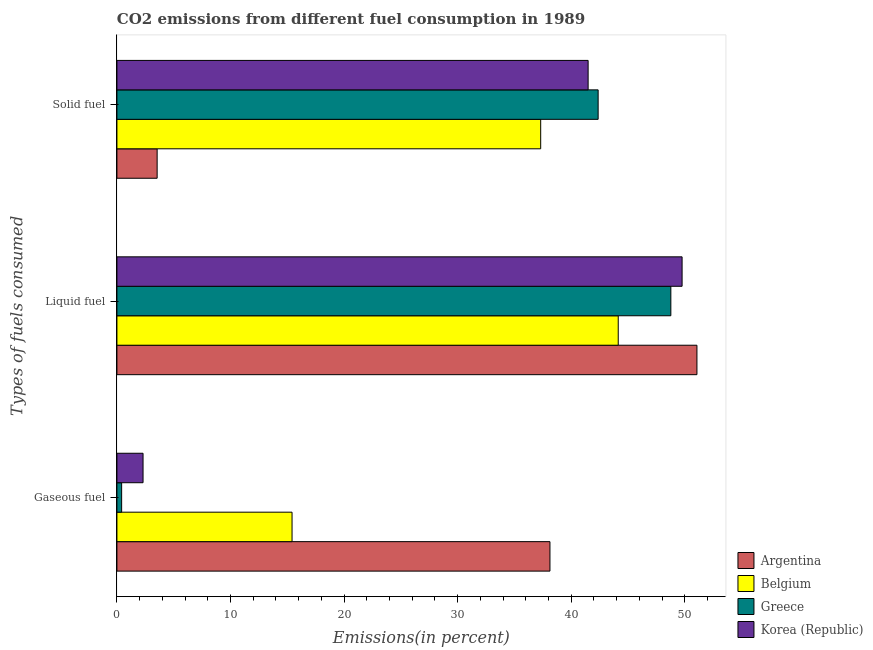Are the number of bars per tick equal to the number of legend labels?
Give a very brief answer. Yes. Are the number of bars on each tick of the Y-axis equal?
Offer a terse response. Yes. What is the label of the 1st group of bars from the top?
Your answer should be compact. Solid fuel. What is the percentage of liquid fuel emission in Korea (Republic)?
Offer a terse response. 49.77. Across all countries, what is the maximum percentage of liquid fuel emission?
Provide a succinct answer. 51.07. Across all countries, what is the minimum percentage of liquid fuel emission?
Your answer should be very brief. 44.14. In which country was the percentage of solid fuel emission minimum?
Keep it short and to the point. Argentina. What is the total percentage of solid fuel emission in the graph?
Your answer should be very brief. 124.72. What is the difference between the percentage of solid fuel emission in Argentina and that in Belgium?
Offer a very short reply. -33.77. What is the difference between the percentage of liquid fuel emission in Argentina and the percentage of gaseous fuel emission in Greece?
Your answer should be very brief. 50.66. What is the average percentage of liquid fuel emission per country?
Keep it short and to the point. 48.44. What is the difference between the percentage of gaseous fuel emission and percentage of liquid fuel emission in Greece?
Provide a succinct answer. -48.36. What is the ratio of the percentage of liquid fuel emission in Argentina to that in Greece?
Your answer should be very brief. 1.05. What is the difference between the highest and the second highest percentage of gaseous fuel emission?
Provide a succinct answer. 22.71. What is the difference between the highest and the lowest percentage of liquid fuel emission?
Your response must be concise. 6.93. What does the 2nd bar from the top in Liquid fuel represents?
Your response must be concise. Greece. What does the 1st bar from the bottom in Liquid fuel represents?
Provide a short and direct response. Argentina. Is it the case that in every country, the sum of the percentage of gaseous fuel emission and percentage of liquid fuel emission is greater than the percentage of solid fuel emission?
Give a very brief answer. Yes. Are all the bars in the graph horizontal?
Give a very brief answer. Yes. How many countries are there in the graph?
Ensure brevity in your answer.  4. Are the values on the major ticks of X-axis written in scientific E-notation?
Provide a succinct answer. No. Does the graph contain grids?
Give a very brief answer. No. What is the title of the graph?
Your response must be concise. CO2 emissions from different fuel consumption in 1989. What is the label or title of the X-axis?
Give a very brief answer. Emissions(in percent). What is the label or title of the Y-axis?
Your response must be concise. Types of fuels consumed. What is the Emissions(in percent) of Argentina in Gaseous fuel?
Offer a terse response. 38.13. What is the Emissions(in percent) of Belgium in Gaseous fuel?
Ensure brevity in your answer.  15.42. What is the Emissions(in percent) of Greece in Gaseous fuel?
Offer a very short reply. 0.42. What is the Emissions(in percent) in Korea (Republic) in Gaseous fuel?
Your answer should be compact. 2.3. What is the Emissions(in percent) in Argentina in Liquid fuel?
Ensure brevity in your answer.  51.07. What is the Emissions(in percent) of Belgium in Liquid fuel?
Ensure brevity in your answer.  44.14. What is the Emissions(in percent) of Greece in Liquid fuel?
Your answer should be compact. 48.77. What is the Emissions(in percent) in Korea (Republic) in Liquid fuel?
Give a very brief answer. 49.77. What is the Emissions(in percent) of Argentina in Solid fuel?
Provide a succinct answer. 3.54. What is the Emissions(in percent) in Belgium in Solid fuel?
Provide a succinct answer. 37.31. What is the Emissions(in percent) of Greece in Solid fuel?
Provide a short and direct response. 42.37. What is the Emissions(in percent) in Korea (Republic) in Solid fuel?
Offer a very short reply. 41.49. Across all Types of fuels consumed, what is the maximum Emissions(in percent) in Argentina?
Give a very brief answer. 51.07. Across all Types of fuels consumed, what is the maximum Emissions(in percent) in Belgium?
Provide a short and direct response. 44.14. Across all Types of fuels consumed, what is the maximum Emissions(in percent) of Greece?
Your answer should be compact. 48.77. Across all Types of fuels consumed, what is the maximum Emissions(in percent) of Korea (Republic)?
Your answer should be compact. 49.77. Across all Types of fuels consumed, what is the minimum Emissions(in percent) of Argentina?
Offer a very short reply. 3.54. Across all Types of fuels consumed, what is the minimum Emissions(in percent) in Belgium?
Give a very brief answer. 15.42. Across all Types of fuels consumed, what is the minimum Emissions(in percent) of Greece?
Ensure brevity in your answer.  0.42. Across all Types of fuels consumed, what is the minimum Emissions(in percent) of Korea (Republic)?
Your answer should be very brief. 2.3. What is the total Emissions(in percent) of Argentina in the graph?
Offer a terse response. 92.74. What is the total Emissions(in percent) in Belgium in the graph?
Offer a very short reply. 96.88. What is the total Emissions(in percent) of Greece in the graph?
Provide a succinct answer. 91.56. What is the total Emissions(in percent) of Korea (Republic) in the graph?
Give a very brief answer. 93.56. What is the difference between the Emissions(in percent) in Argentina in Gaseous fuel and that in Liquid fuel?
Offer a very short reply. -12.94. What is the difference between the Emissions(in percent) in Belgium in Gaseous fuel and that in Liquid fuel?
Ensure brevity in your answer.  -28.72. What is the difference between the Emissions(in percent) in Greece in Gaseous fuel and that in Liquid fuel?
Make the answer very short. -48.36. What is the difference between the Emissions(in percent) in Korea (Republic) in Gaseous fuel and that in Liquid fuel?
Your answer should be compact. -47.46. What is the difference between the Emissions(in percent) in Argentina in Gaseous fuel and that in Solid fuel?
Provide a succinct answer. 34.59. What is the difference between the Emissions(in percent) in Belgium in Gaseous fuel and that in Solid fuel?
Provide a succinct answer. -21.89. What is the difference between the Emissions(in percent) of Greece in Gaseous fuel and that in Solid fuel?
Provide a short and direct response. -41.96. What is the difference between the Emissions(in percent) in Korea (Republic) in Gaseous fuel and that in Solid fuel?
Offer a terse response. -39.19. What is the difference between the Emissions(in percent) of Argentina in Liquid fuel and that in Solid fuel?
Provide a succinct answer. 47.53. What is the difference between the Emissions(in percent) of Belgium in Liquid fuel and that in Solid fuel?
Your answer should be compact. 6.83. What is the difference between the Emissions(in percent) of Greece in Liquid fuel and that in Solid fuel?
Give a very brief answer. 6.4. What is the difference between the Emissions(in percent) of Korea (Republic) in Liquid fuel and that in Solid fuel?
Provide a short and direct response. 8.27. What is the difference between the Emissions(in percent) in Argentina in Gaseous fuel and the Emissions(in percent) in Belgium in Liquid fuel?
Provide a succinct answer. -6.01. What is the difference between the Emissions(in percent) in Argentina in Gaseous fuel and the Emissions(in percent) in Greece in Liquid fuel?
Your answer should be compact. -10.64. What is the difference between the Emissions(in percent) of Argentina in Gaseous fuel and the Emissions(in percent) of Korea (Republic) in Liquid fuel?
Your response must be concise. -11.64. What is the difference between the Emissions(in percent) in Belgium in Gaseous fuel and the Emissions(in percent) in Greece in Liquid fuel?
Keep it short and to the point. -33.35. What is the difference between the Emissions(in percent) in Belgium in Gaseous fuel and the Emissions(in percent) in Korea (Republic) in Liquid fuel?
Provide a succinct answer. -34.34. What is the difference between the Emissions(in percent) of Greece in Gaseous fuel and the Emissions(in percent) of Korea (Republic) in Liquid fuel?
Provide a succinct answer. -49.35. What is the difference between the Emissions(in percent) of Argentina in Gaseous fuel and the Emissions(in percent) of Belgium in Solid fuel?
Your response must be concise. 0.81. What is the difference between the Emissions(in percent) of Argentina in Gaseous fuel and the Emissions(in percent) of Greece in Solid fuel?
Offer a very short reply. -4.24. What is the difference between the Emissions(in percent) of Argentina in Gaseous fuel and the Emissions(in percent) of Korea (Republic) in Solid fuel?
Provide a succinct answer. -3.36. What is the difference between the Emissions(in percent) in Belgium in Gaseous fuel and the Emissions(in percent) in Greece in Solid fuel?
Keep it short and to the point. -26.95. What is the difference between the Emissions(in percent) in Belgium in Gaseous fuel and the Emissions(in percent) in Korea (Republic) in Solid fuel?
Ensure brevity in your answer.  -26.07. What is the difference between the Emissions(in percent) in Greece in Gaseous fuel and the Emissions(in percent) in Korea (Republic) in Solid fuel?
Make the answer very short. -41.08. What is the difference between the Emissions(in percent) of Argentina in Liquid fuel and the Emissions(in percent) of Belgium in Solid fuel?
Ensure brevity in your answer.  13.76. What is the difference between the Emissions(in percent) of Argentina in Liquid fuel and the Emissions(in percent) of Greece in Solid fuel?
Offer a very short reply. 8.7. What is the difference between the Emissions(in percent) of Argentina in Liquid fuel and the Emissions(in percent) of Korea (Republic) in Solid fuel?
Give a very brief answer. 9.58. What is the difference between the Emissions(in percent) of Belgium in Liquid fuel and the Emissions(in percent) of Greece in Solid fuel?
Keep it short and to the point. 1.77. What is the difference between the Emissions(in percent) in Belgium in Liquid fuel and the Emissions(in percent) in Korea (Republic) in Solid fuel?
Give a very brief answer. 2.65. What is the difference between the Emissions(in percent) of Greece in Liquid fuel and the Emissions(in percent) of Korea (Republic) in Solid fuel?
Provide a succinct answer. 7.28. What is the average Emissions(in percent) of Argentina per Types of fuels consumed?
Ensure brevity in your answer.  30.91. What is the average Emissions(in percent) in Belgium per Types of fuels consumed?
Offer a very short reply. 32.29. What is the average Emissions(in percent) in Greece per Types of fuels consumed?
Offer a very short reply. 30.52. What is the average Emissions(in percent) of Korea (Republic) per Types of fuels consumed?
Provide a succinct answer. 31.19. What is the difference between the Emissions(in percent) in Argentina and Emissions(in percent) in Belgium in Gaseous fuel?
Your answer should be very brief. 22.71. What is the difference between the Emissions(in percent) of Argentina and Emissions(in percent) of Greece in Gaseous fuel?
Offer a terse response. 37.71. What is the difference between the Emissions(in percent) in Argentina and Emissions(in percent) in Korea (Republic) in Gaseous fuel?
Provide a succinct answer. 35.83. What is the difference between the Emissions(in percent) in Belgium and Emissions(in percent) in Greece in Gaseous fuel?
Make the answer very short. 15.01. What is the difference between the Emissions(in percent) in Belgium and Emissions(in percent) in Korea (Republic) in Gaseous fuel?
Keep it short and to the point. 13.12. What is the difference between the Emissions(in percent) in Greece and Emissions(in percent) in Korea (Republic) in Gaseous fuel?
Your answer should be compact. -1.89. What is the difference between the Emissions(in percent) in Argentina and Emissions(in percent) in Belgium in Liquid fuel?
Your answer should be compact. 6.93. What is the difference between the Emissions(in percent) of Argentina and Emissions(in percent) of Greece in Liquid fuel?
Offer a very short reply. 2.3. What is the difference between the Emissions(in percent) in Argentina and Emissions(in percent) in Korea (Republic) in Liquid fuel?
Keep it short and to the point. 1.31. What is the difference between the Emissions(in percent) of Belgium and Emissions(in percent) of Greece in Liquid fuel?
Your answer should be compact. -4.63. What is the difference between the Emissions(in percent) in Belgium and Emissions(in percent) in Korea (Republic) in Liquid fuel?
Your response must be concise. -5.62. What is the difference between the Emissions(in percent) in Greece and Emissions(in percent) in Korea (Republic) in Liquid fuel?
Ensure brevity in your answer.  -0.99. What is the difference between the Emissions(in percent) in Argentina and Emissions(in percent) in Belgium in Solid fuel?
Provide a succinct answer. -33.77. What is the difference between the Emissions(in percent) in Argentina and Emissions(in percent) in Greece in Solid fuel?
Make the answer very short. -38.83. What is the difference between the Emissions(in percent) of Argentina and Emissions(in percent) of Korea (Republic) in Solid fuel?
Your answer should be very brief. -37.95. What is the difference between the Emissions(in percent) of Belgium and Emissions(in percent) of Greece in Solid fuel?
Make the answer very short. -5.06. What is the difference between the Emissions(in percent) in Belgium and Emissions(in percent) in Korea (Republic) in Solid fuel?
Make the answer very short. -4.18. What is the difference between the Emissions(in percent) of Greece and Emissions(in percent) of Korea (Republic) in Solid fuel?
Your answer should be compact. 0.88. What is the ratio of the Emissions(in percent) in Argentina in Gaseous fuel to that in Liquid fuel?
Your response must be concise. 0.75. What is the ratio of the Emissions(in percent) in Belgium in Gaseous fuel to that in Liquid fuel?
Offer a very short reply. 0.35. What is the ratio of the Emissions(in percent) of Greece in Gaseous fuel to that in Liquid fuel?
Ensure brevity in your answer.  0.01. What is the ratio of the Emissions(in percent) in Korea (Republic) in Gaseous fuel to that in Liquid fuel?
Provide a short and direct response. 0.05. What is the ratio of the Emissions(in percent) in Argentina in Gaseous fuel to that in Solid fuel?
Provide a short and direct response. 10.76. What is the ratio of the Emissions(in percent) in Belgium in Gaseous fuel to that in Solid fuel?
Make the answer very short. 0.41. What is the ratio of the Emissions(in percent) of Greece in Gaseous fuel to that in Solid fuel?
Make the answer very short. 0.01. What is the ratio of the Emissions(in percent) in Korea (Republic) in Gaseous fuel to that in Solid fuel?
Your answer should be very brief. 0.06. What is the ratio of the Emissions(in percent) in Argentina in Liquid fuel to that in Solid fuel?
Your answer should be very brief. 14.42. What is the ratio of the Emissions(in percent) in Belgium in Liquid fuel to that in Solid fuel?
Offer a terse response. 1.18. What is the ratio of the Emissions(in percent) in Greece in Liquid fuel to that in Solid fuel?
Offer a terse response. 1.15. What is the ratio of the Emissions(in percent) of Korea (Republic) in Liquid fuel to that in Solid fuel?
Your answer should be compact. 1.2. What is the difference between the highest and the second highest Emissions(in percent) of Argentina?
Your answer should be compact. 12.94. What is the difference between the highest and the second highest Emissions(in percent) of Belgium?
Ensure brevity in your answer.  6.83. What is the difference between the highest and the second highest Emissions(in percent) of Greece?
Provide a succinct answer. 6.4. What is the difference between the highest and the second highest Emissions(in percent) of Korea (Republic)?
Your answer should be very brief. 8.27. What is the difference between the highest and the lowest Emissions(in percent) of Argentina?
Provide a succinct answer. 47.53. What is the difference between the highest and the lowest Emissions(in percent) of Belgium?
Keep it short and to the point. 28.72. What is the difference between the highest and the lowest Emissions(in percent) of Greece?
Give a very brief answer. 48.36. What is the difference between the highest and the lowest Emissions(in percent) of Korea (Republic)?
Offer a terse response. 47.46. 